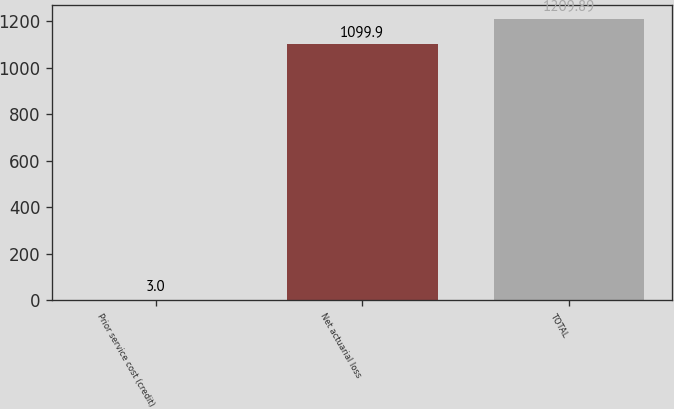Convert chart to OTSL. <chart><loc_0><loc_0><loc_500><loc_500><bar_chart><fcel>Prior service cost (credit)<fcel>Net actuarial loss<fcel>TOTAL<nl><fcel>3<fcel>1099.9<fcel>1209.89<nl></chart> 